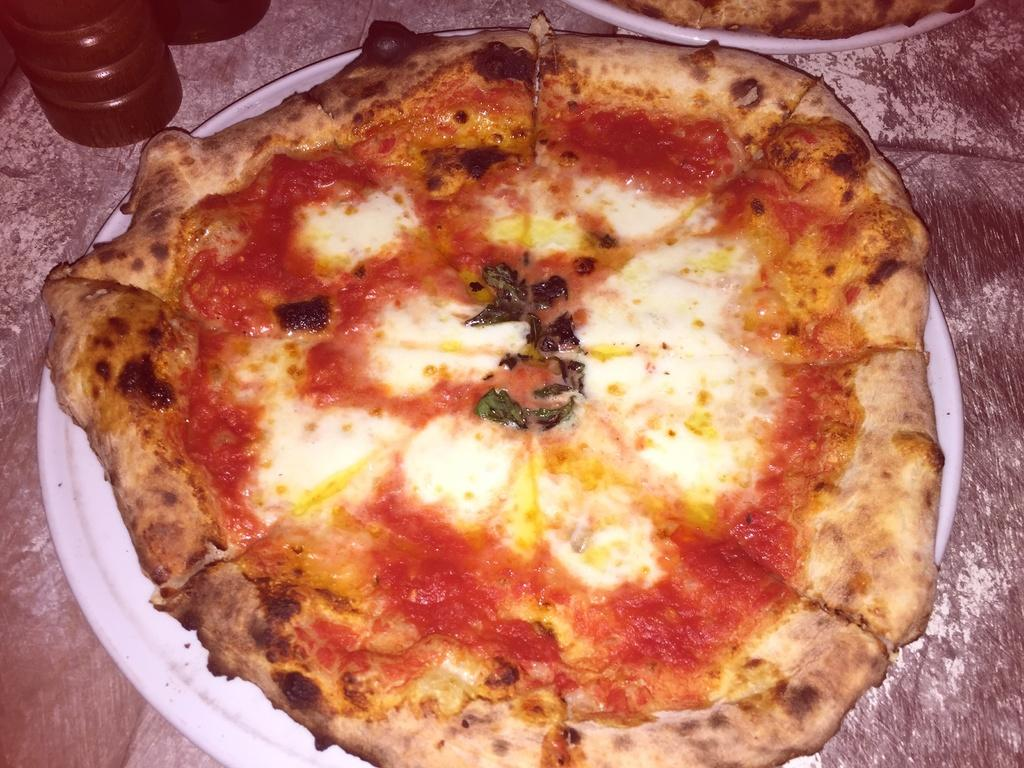What type of food is on the plates in the image? There are two plates containing pizzas in the image. Where are the plates with pizzas located? The plates are placed on a table. What can be seen in the image besides the plates with pizzas? There is a red color bottle in the image. How does the person in the image control the temperature of the pizza? There is no person present in the image, and therefore no one is controlling the temperature of the pizza. 